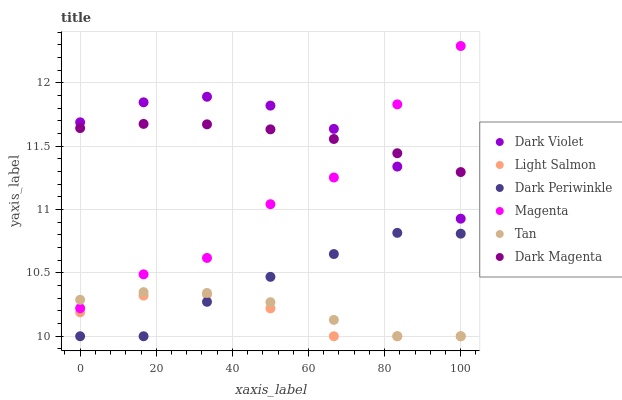Does Light Salmon have the minimum area under the curve?
Answer yes or no. Yes. Does Dark Violet have the maximum area under the curve?
Answer yes or no. Yes. Does Dark Magenta have the minimum area under the curve?
Answer yes or no. No. Does Dark Magenta have the maximum area under the curve?
Answer yes or no. No. Is Dark Magenta the smoothest?
Answer yes or no. Yes. Is Magenta the roughest?
Answer yes or no. Yes. Is Dark Violet the smoothest?
Answer yes or no. No. Is Dark Violet the roughest?
Answer yes or no. No. Does Light Salmon have the lowest value?
Answer yes or no. Yes. Does Dark Violet have the lowest value?
Answer yes or no. No. Does Magenta have the highest value?
Answer yes or no. Yes. Does Dark Magenta have the highest value?
Answer yes or no. No. Is Dark Periwinkle less than Dark Violet?
Answer yes or no. Yes. Is Dark Magenta greater than Tan?
Answer yes or no. Yes. Does Light Salmon intersect Tan?
Answer yes or no. Yes. Is Light Salmon less than Tan?
Answer yes or no. No. Is Light Salmon greater than Tan?
Answer yes or no. No. Does Dark Periwinkle intersect Dark Violet?
Answer yes or no. No. 